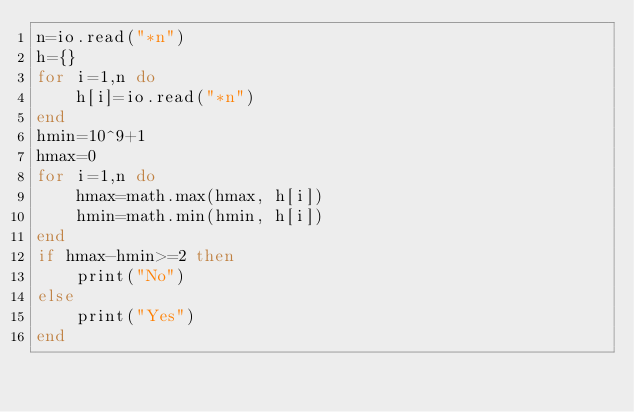<code> <loc_0><loc_0><loc_500><loc_500><_Lua_>n=io.read("*n")
h={}
for i=1,n do
    h[i]=io.read("*n")
end
hmin=10^9+1
hmax=0
for i=1,n do
    hmax=math.max(hmax, h[i])
    hmin=math.min(hmin, h[i])
end
if hmax-hmin>=2 then
    print("No")
else
    print("Yes")
end</code> 